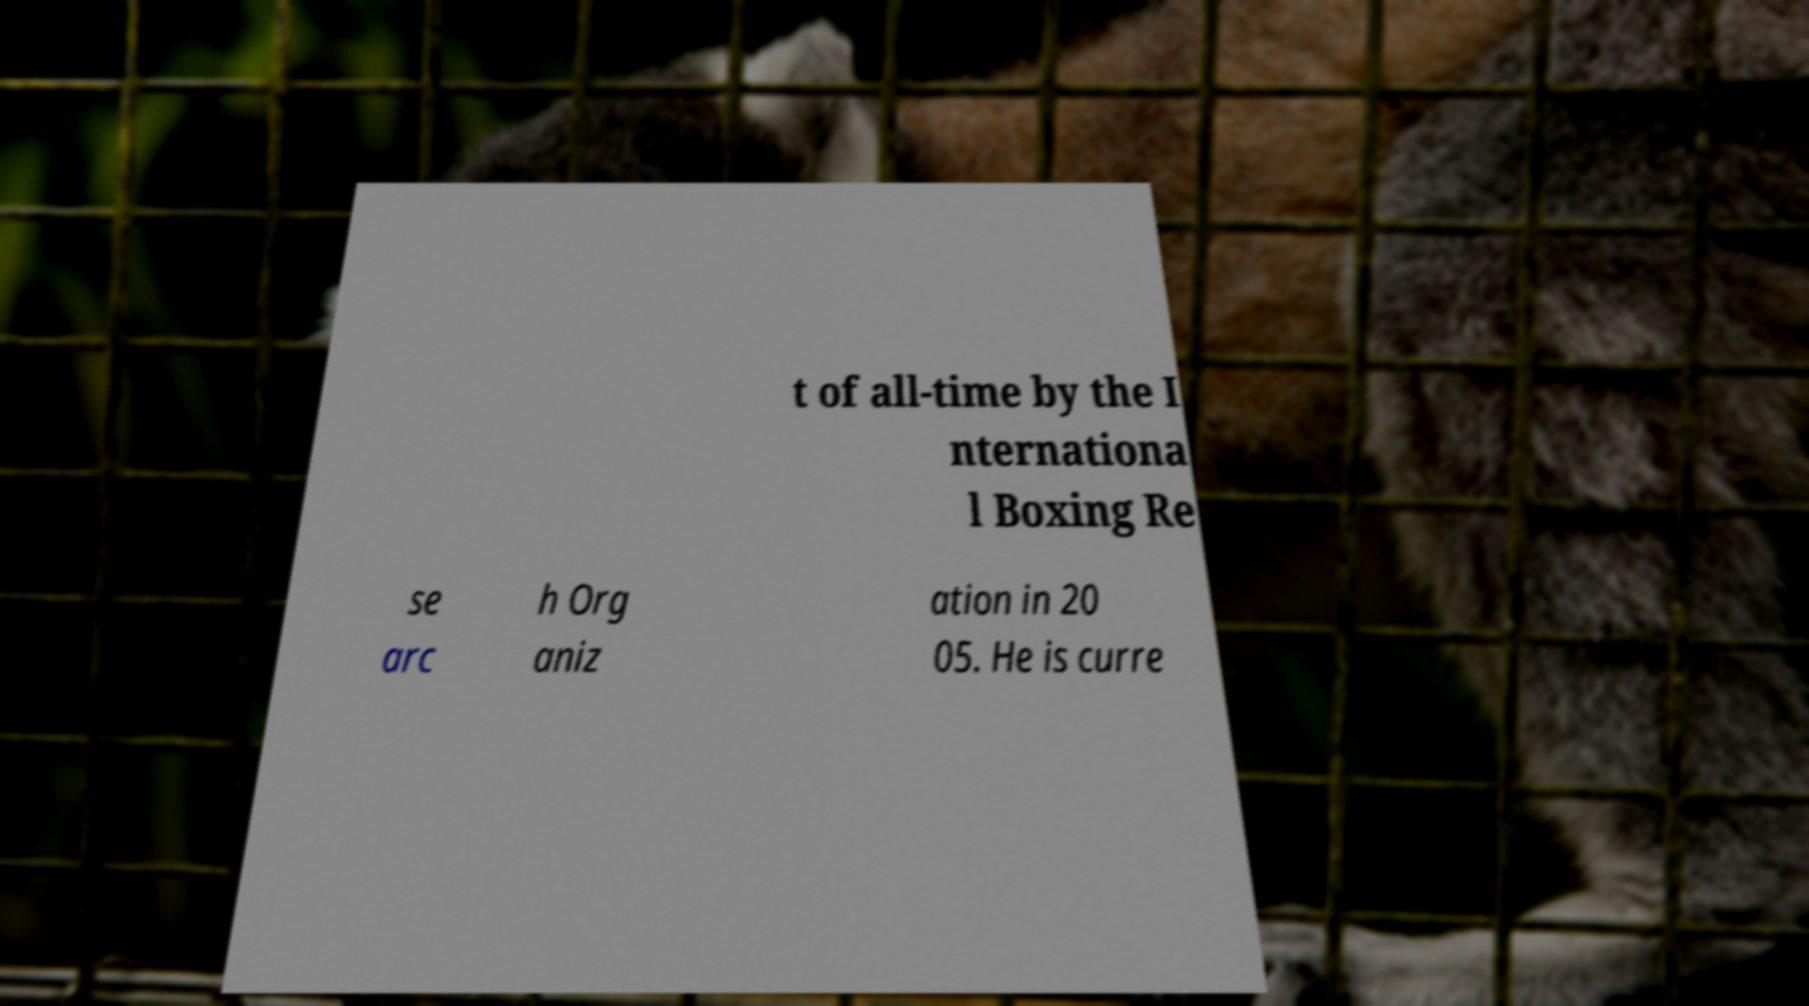Could you assist in decoding the text presented in this image and type it out clearly? t of all-time by the I nternationa l Boxing Re se arc h Org aniz ation in 20 05. He is curre 